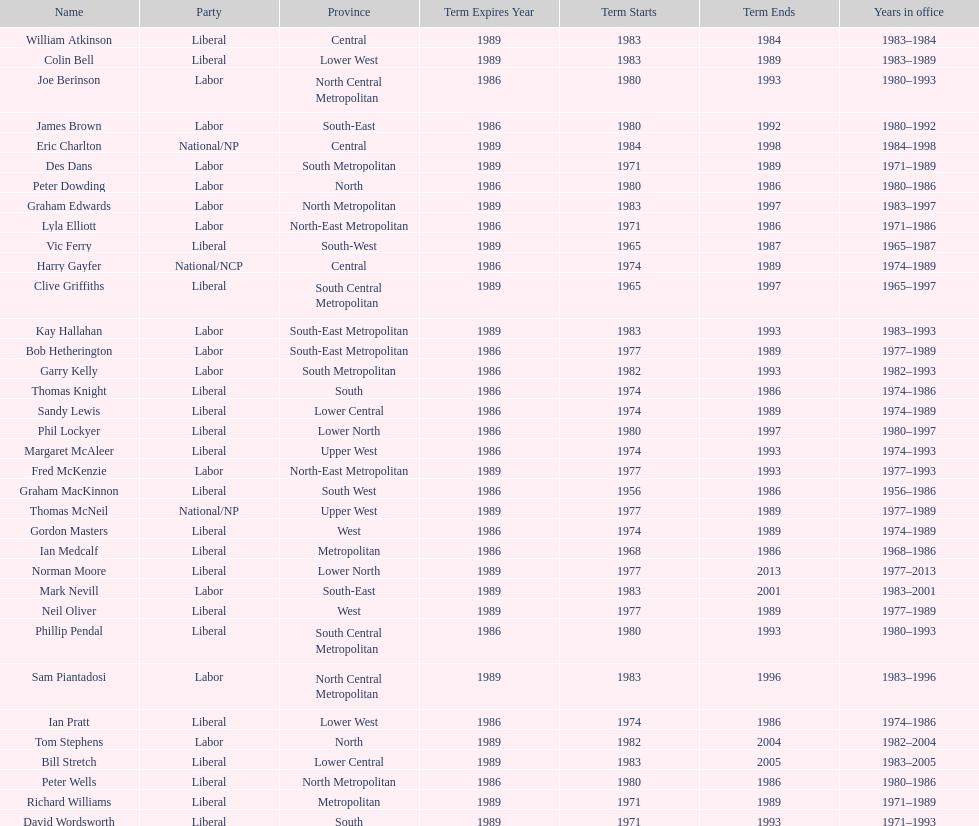Who has had the shortest term in office William Atkinson. 